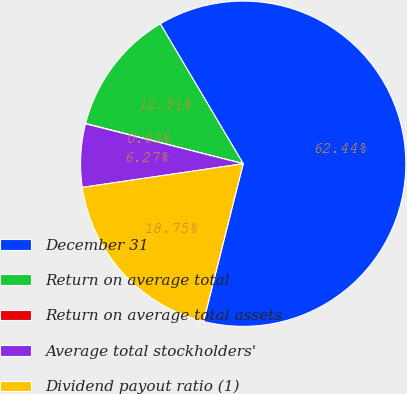Convert chart. <chart><loc_0><loc_0><loc_500><loc_500><pie_chart><fcel>December 31<fcel>Return on average total<fcel>Return on average total assets<fcel>Average total stockholders'<fcel>Dividend payout ratio (1)<nl><fcel>62.44%<fcel>12.51%<fcel>0.03%<fcel>6.27%<fcel>18.75%<nl></chart> 